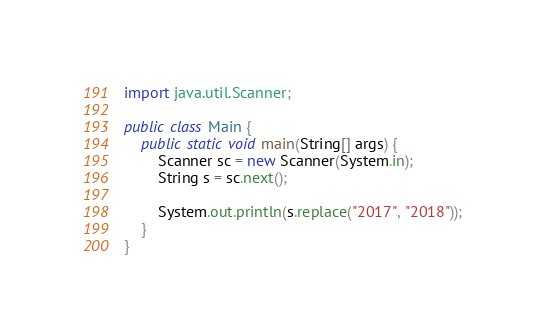Convert code to text. <code><loc_0><loc_0><loc_500><loc_500><_Java_>import java.util.Scanner;

public class Main {
    public static void main(String[] args) {
        Scanner sc = new Scanner(System.in);
        String s = sc.next();

        System.out.println(s.replace("2017", "2018"));
    }
}
</code> 